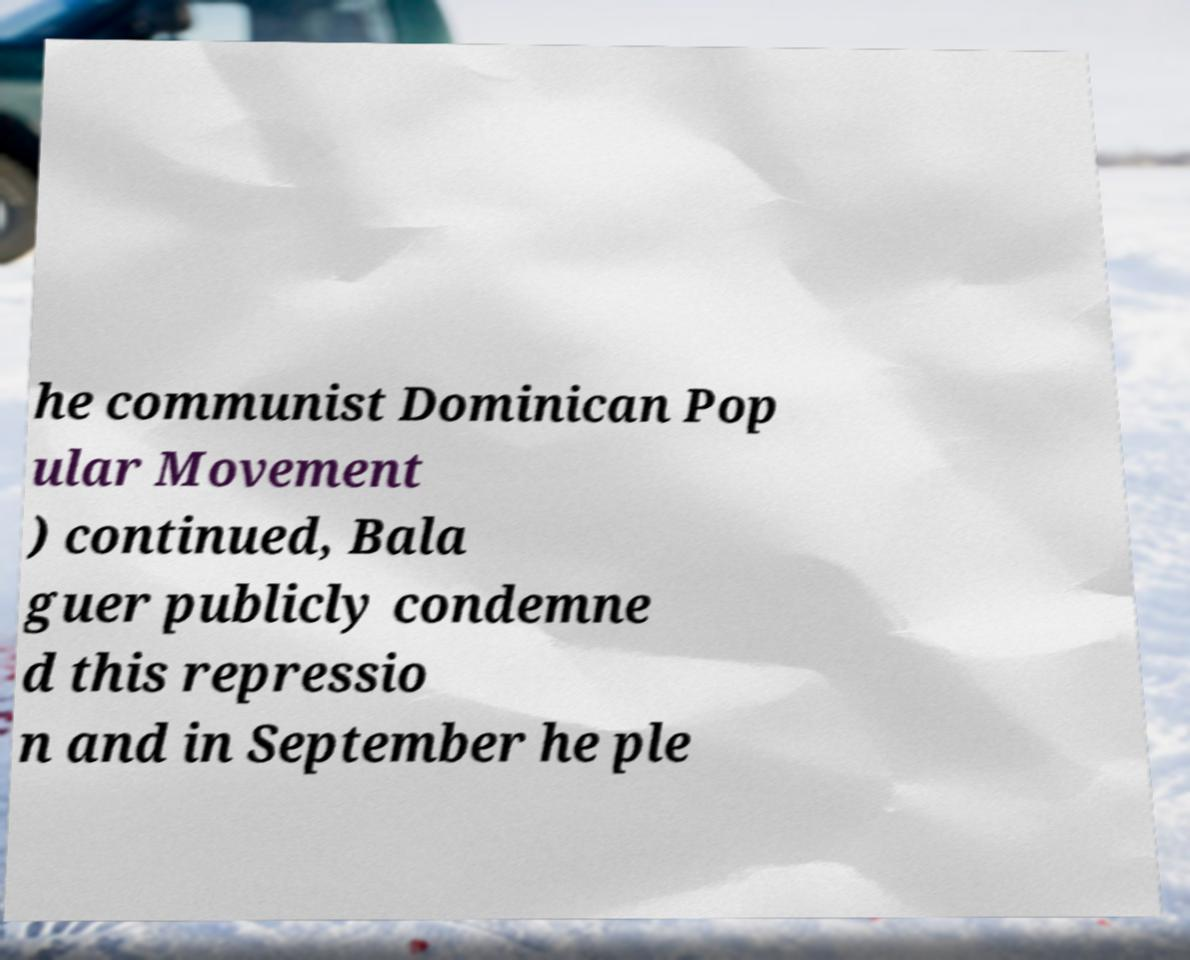Can you read and provide the text displayed in the image?This photo seems to have some interesting text. Can you extract and type it out for me? he communist Dominican Pop ular Movement ) continued, Bala guer publicly condemne d this repressio n and in September he ple 